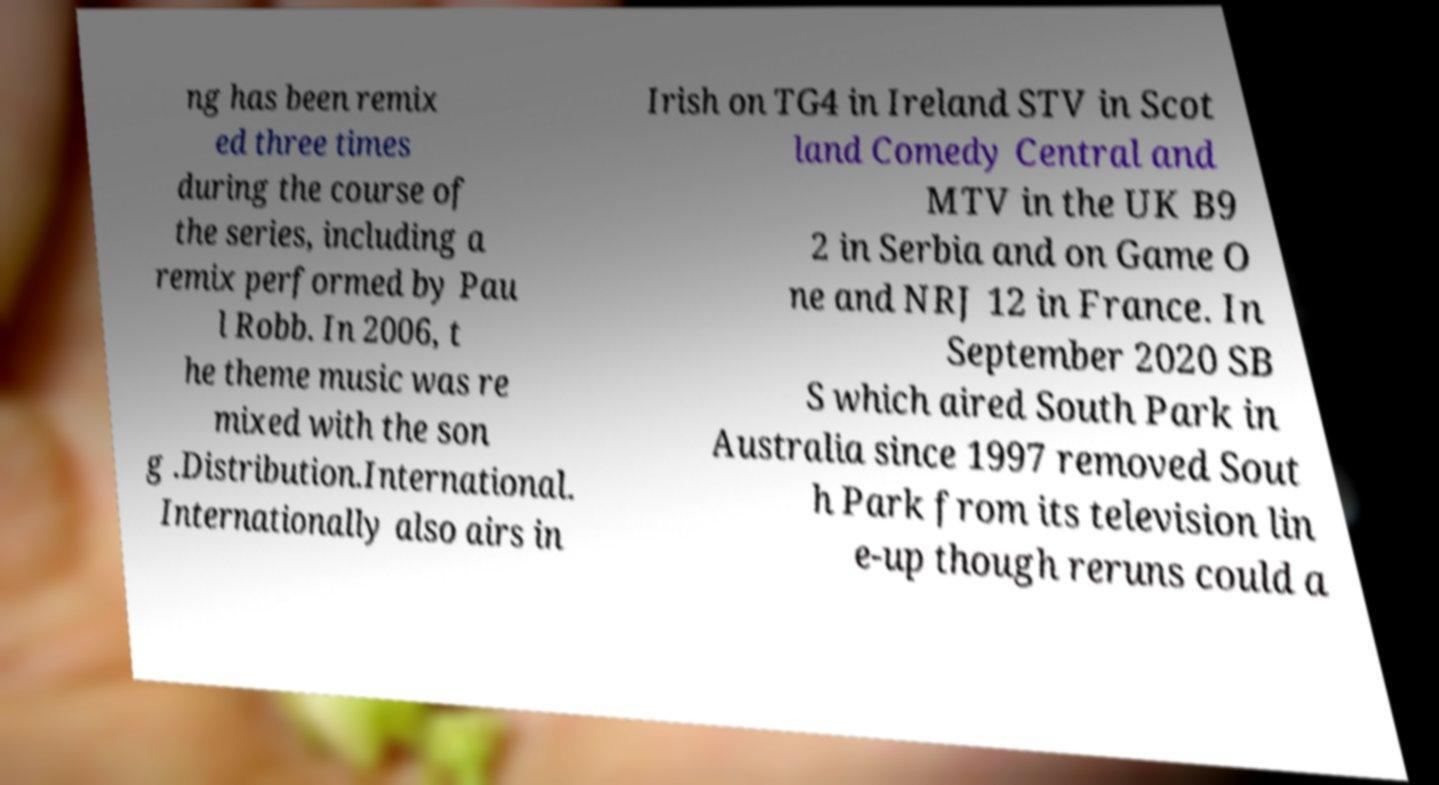Can you read and provide the text displayed in the image?This photo seems to have some interesting text. Can you extract and type it out for me? ng has been remix ed three times during the course of the series, including a remix performed by Pau l Robb. In 2006, t he theme music was re mixed with the son g .Distribution.International. Internationally also airs in Irish on TG4 in Ireland STV in Scot land Comedy Central and MTV in the UK B9 2 in Serbia and on Game O ne and NRJ 12 in France. In September 2020 SB S which aired South Park in Australia since 1997 removed Sout h Park from its television lin e-up though reruns could a 